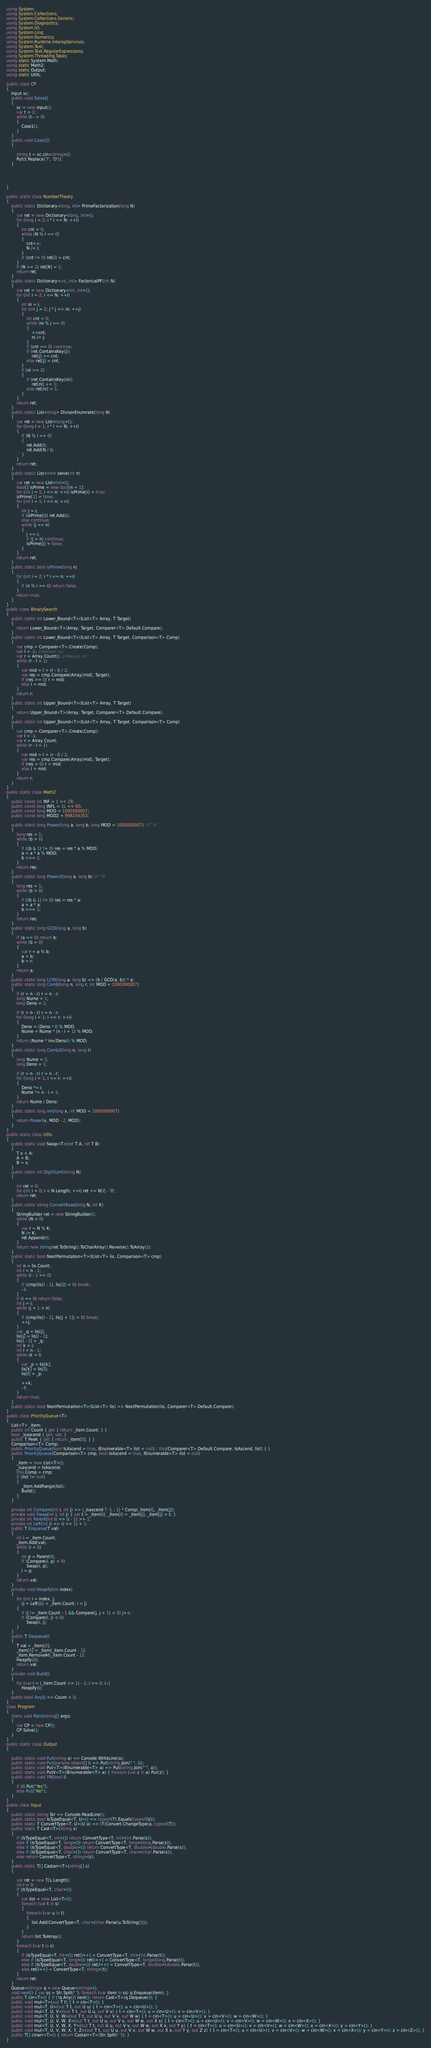Convert code to text. <code><loc_0><loc_0><loc_500><loc_500><_C#_>using System;
using System.Collections;
using System.Collections.Generic;
using System.Diagnostics;
using System.IO;
using System.Linq;
using System.Numerics;
using System.Runtime.InteropServices;
using System.Text;
using System.Text.RegularExpressions;
using System.Threading.Tasks;
using static System.Math;
using static Math2;
using static Output;
using static Utils;

public class CP
{
    Input sc;
    public void Solve()
    {
        sc = new Input();
        var t = 1;
        while (t-- > 0)
        {
            Case1();
        }
    }
    public void Case1()
    {

        string t = sc.cin<string>();
        Put(t.Replace('?', 'D'));
    }




}

public static class NumberTheory
{
    public static Dictionary<long, int> PrimeFactorization(long N)
    {
        var ret = new Dictionary<long, int>();
        for (long i = 2; i * i <= N; ++i)
        {
            int cnt = 0;
            while (N % i == 0)
            {
                cnt++;
                N /= i;
            }
            if (cnt != 0) ret[i] = cnt;
        }
        if (N >= 2) ret[N] = 1;
        return ret;
    }
    public static Dictionary<int, int> FactoricalPF(int N)
    {
        var ret = new Dictionary<int, int>();
        for (int i = 2; i <= N; ++i)
        {
            int ni = i;
            for (int j = 2; j * j <= ni; ++j)
            {
                int cnt = 0;
                while (ni % j == 0)
                {
                    ++cnt;
                    ni /= j;
                }
                if (cnt == 0) continue;
                if (ret.ContainsKey(j))
                    ret[j] += cnt;
                else ret[j] = cnt;
            }
            if (ni >= 2)
            {
                if (ret.ContainsKey(ni))
                    ret[ni] += 1;
                else ret[ni] = 1;
            }
        }
        return ret;
    }
    public static List<long> DivisorEnumrate(long N)
    {
        var ret = new List<long>();
        for (long i = 1; i * i <= N; ++i)
        {
            if (N % i == 0)
            {
                ret.Add(i);
                ret.Add(N / i);
            }
        }
        return ret;
    }
    public static List<int> seive(int n)
    {
        var ret = new List<int>();
        bool[] isPrime = new bool[n + 1];
        for (int i = 1; i <= n; ++i) isPrime[i] = true;
        isPrime[1] = false;
        for (int i = 1; i <= n; ++i)
        {
            int j = i;
            if (isPrime[i]) ret.Add(i);
            else continue;
            while (j <= n)
            {
                j += i;
                if (j > n) continue;
                isPrime[j] = false;
            }
        }
        return ret;
    }
    public static bool isPrime(long n)
    {
        for (int i = 2; i * i <= n; ++i)
        {
            if (n % i == 0) return false;
        }
        return true;
    }
}
public class BinarySearch
{
    public static int Lower_Bound<T>(IList<T> Array, T Target)
    {
        return Lower_Bound<T>(Array, Target, Comparer<T>.Default.Compare);
    }
    public static int Lower_Bound<T>(IList<T> Array, T Target, Comparison<T> Comp)
    {
        var cmp = Comparer<T>.Create(Comp);
        var l = -1; //always ng
        var r = Array.Count(); //always ok
        while (r - l > 1)
        {
            var mid = l + (r - l) / 2;
            var res = cmp.Compare(Array[mid], Target);
            if (res >= 0) r = mid;
            else l = mid;
        }
        return r;
    }
    public static int Upper_Bound<T>(IList<T> Array, T Target)
    {
        return Upper_Bound<T>(Array, Target, Comparer<T>.Default.Compare);
    }
    public static int Upper_Bound<T>(IList<T> Array, T Target, Comparison<T> Comp)
    {
        var cmp = Comparer<T>.Create(Comp);
        var l = -1;
        var r = Array.Count;
        while (r - l > 1)
        {
            var mid = l + (r - l) / 2;
            var res = cmp.Compare(Array[mid], Target);
            if (res > 0) r = mid;
            else l = mid;
        }
        return r;
    }
}
public static class Math2
{
    public const int INF = 1 << 29;
    public const long INFL = 1L << 60;
    public const long MOD = 1000000007;
    public const long MOD2 = 998244353;

    public static long Power(long a, long b, long MOD = 1000000007) //i^N
    {
        long res = 1;
        while (b > 0)
        {
            if ((b & 1) != 0) res = res * a % MOD;
            a = a * a % MOD;
            b >>= 1;
        }
        return res;
    }
    public static long Power2(long a, long b) //i^N
    {
        long res = 1;
        while (b > 0)
        {
            if ((b & 1) != 0) res = res * a;
            a = a * a;
            b >>= 1;
        }
        return res;
    }
    public static long GCD(long a, long b)
    {
        if (a == 0) return b;
        while (b > 0)
        {
            var r = a % b;
            a = b;
            b = r;
        }
        return a;
    }
    public static long LCM(long a, long b) => (b / GCD(a, b)) * a;
    public static long Comb(long n, long r, int MOD = 1000000007)
    {
        if (r > n - r) r = n - r;
        long Nume = 1;
        long Deno = 1;

        if (r > n - r) r = n - r;
        for (long i = 1; i <= r; ++i)
        {
            Deno = (Deno * i) % MOD;
            Nume = Nume * (n - i + 1) % MOD;
        }
        return (Nume * inv(Deno)) % MOD;
    }
    public static long Comb2(long n, long r)
    {
        long Nume = 1;
        long Deno = 1;

        if (r > n - r) r = n - r;
        for (long i = 1; i <= r; ++i)
        {
            Deno *= i;
            Nume *= n - i + 1;
        }
        return Nume / Deno;
    }
    public static long inv(long x, int MOD = 1000000007)
    {
        return Power(x, MOD - 2, MOD);
    }
}
public static class Utils
{
    public static void Swap<T>(ref T A, ref T B)
    {
        T x = A;
        A = B;
        B = x;
    }
    public static int DigitSum(string N)
    {

        int ret = 0;
        for (int i = 0; i < N.Length; ++i) ret += N[i] - '0';
        return ret;
    }
    public static string ConvertBase(long N, int K)
    {
        StringBuilder ret = new StringBuilder();
        while (N > 0)
        {
            var r = N % K;
            N /= K;
            ret.Append(r);
        }
        return new string(ret.ToString().ToCharArray().Reverse().ToArray());
    }
    public static bool NextPermutation<T>(IList<T> lis, Comparison<T> cmp)
    {
        int n = lis.Count;
        int i = n - 1;
        while (i - 1 >= 0)
        {
            if (cmp(lis[i - 1], lis[i]) < 0) break;
            --i;
        }
        if (i == 0) return false;
        int j = i;
        while (j + 1 < n)
        {
            if (cmp(lis[i - 1], lis[j + 1]) > 0) break;
            ++j;
        }
        var _q = lis[j];
        lis[j] = lis[i - 1];
        lis[i - 1] = _q;
        int k = i;
        int l = n - 1;
        while (k < l)
        {
            var _p = lis[k];
            lis[k] = lis[l];
            lis[l] = _p;

            ++k;
            --l;
        }
        return true;
    }
    public static bool NextPermutation<T>(IList<T> lis) => NextPermutation(lis, Comparer<T>.Default.Compare);
}
public class PriorityQueue<T>
{
    List<T> _item;
    public int Count { get { return _item.Count; } }
    bool _isascend { get; set; }
    public T Peek { get { return _item[0]; } }
    Comparison<T> Comp;
    public PriorityQueue(bool IsAscend = true, IEnumerable<T> list = null) : this(Comparer<T>.Default.Compare, IsAscend, list) { }
    public PriorityQueue(Comparison<T> cmp, bool IsAscend = true, IEnumerable<T> list = null)
    {
        _item = new List<T>();
        _isascend = IsAscend;
        this.Comp = cmp;
        if (list != null)
        {
            _item.AddRange(list);
            Build();
        }
    }

    private int Compare(int i, int j) => (_isascend ? -1 : 1) * Comp(_item[i], _item[j]);
    private void Swap(int i, int j) { var t = _item[i]; _item[i] = _item[j]; _item[j] = t; }
    private int Parent(int i) => (i - 1) >> 1;
    private int Left(int i) => (i << 1) + 1;
    public T Enqueue(T val)
    {
        int i = _item.Count;
        _item.Add(val);
        while (i > 0)
        {
            int p = Parent(i);
            if (Compare(i, p) > 0)
                Swap(i, p);
            i = p;
        }
        return val;
    }
    private void Heapify(int index)
    {
        for (int i = index, j;
            (j = Left(i)) < _item.Count; i = j)
        {
            if (j != _item.Count - 1 && Compare(j, j + 1) < 0) j++;
            if (Compare(i, j) < 0)
                Swap(i, j);
        }
    }
    public T Dequeue()
    {
        T val = _item[0];
        _item[0] = _item[_item.Count - 1];
        _item.RemoveAt(_item.Count - 1);
        Heapify(0);
        return val;
    }
    private void Build()
    {
        for (var i = (_item.Count >> 1) - 1; i >= 0; i--)
            Heapify(i);
    }
    public bool Any() => Count > 0;
}
class Program
{
    static void Main(string[] args)
    {
        var CP = new CP();
        CP.Solve();
    }
}
public static class Output
{

    public static void Put(string a) => Console.WriteLine(a);
    public static void Put(params object[] i) => Put(string.Join(" ", i));
    public static void Put<T>(IEnumerable<T> a) => Put(string.Join(" ", a));
    public static void PutV<T>(IEnumerable<T> a) { foreach (var z in a) Put(z); }
    public static void YN(bool i)
    {
        if (i) Put("Yes");
        else Put("No");
    }
}
public class Input
{
    public static string Str => Console.ReadLine();
    public static bool IsTypeEqual<T, U>() => typeof(T).Equals(typeof(U));
    public static T ConvertType<T, U>(U a) => (T)Convert.ChangeType(a, typeof(T));
    public static T Cast<T>(string s)
    {
        if (IsTypeEqual<T, int>()) return ConvertType<T, int>(int.Parse(s));
        else if (IsTypeEqual<T, long>()) return ConvertType<T, long>(long.Parse(s));
        else if (IsTypeEqual<T, double>()) return ConvertType<T, double>(double.Parse(s));
        else if (IsTypeEqual<T, char>()) return ConvertType<T, char>(char.Parse(s));
        else return ConvertType<T, string>(s);
    }
    public static T[] Castarr<T>(string[] s)
    {

        var ret = new T[s.Length];
        int i = 0;
        if (IsTypeEqual<T, char>())
        {
            var list = new List<T>();
            foreach (var t in s)
            {
                foreach (var u in t)
                {
                    list.Add(ConvertType<T, char>(char.Parse(u.ToString())));
                }
            }
            return list.ToArray();
        }
        foreach (var t in s)
        {
            if (IsTypeEqual<T, int>()) ret[i++] = ConvertType<T, int>(int.Parse(t));
            else if (IsTypeEqual<T, long>()) ret[i++] = ConvertType<T, long>(long.Parse(t));
            else if (IsTypeEqual<T, double>()) ret[i++] = ConvertType<T, double>(double.Parse(t));
            else ret[i++] = ConvertType<T, string>(t);
        }
        return ret;
    }
    Queue<string> q = new Queue<string>();
    void next() { var ss = Str.Split(' '); foreach (var item in ss) q.Enqueue(item); }
    public T cin<T>() { if (!q.Any()) next(); return Cast<T>(q.Dequeue()); }
    public void mul<T>(out T t) { t = cin<T>(); }
    public void mul<T, U>(out T t, out U u) { t = cin<T>(); u = cin<U>(); }
    public void mul<T, U, V>(out T t, out U u, out V v) { t = cin<T>(); u = cin<U>(); v = cin<V>(); }
    public void mul<T, U, V, W>(out T t, out U u, out V v, out W w) { t = cin<T>(); u = cin<U>(); v = cin<V>(); w = cin<W>(); }
    public void mul<T, U, V, W, X>(out T t, out U u, out V v, out W w, out X x) { t = cin<T>(); u = cin<U>(); v = cin<V>(); w = cin<W>(); x = cin<X>(); }
    public void mul<T, U, V, W, X, Y>(out T t, out U u, out V v, out W w, out X x, out Y y) { t = cin<T>(); u = cin<U>(); v = cin<V>(); w = cin<W>(); x = cin<X>(); y = cin<Y>(); }
    public void mul<T, U, V, W, X, Y, Z>(out T t, out U u, out V v, out W w, out X x, out Y y, out Z z) { t = cin<T>(); u = cin<U>(); v = cin<V>(); w = cin<W>(); x = cin<X>(); y = cin<Y>(); z = cin<Z>(); }
    public T[] cinarr<T>() { return Castarr<T>(Str.Split(' ')); }
}</code> 